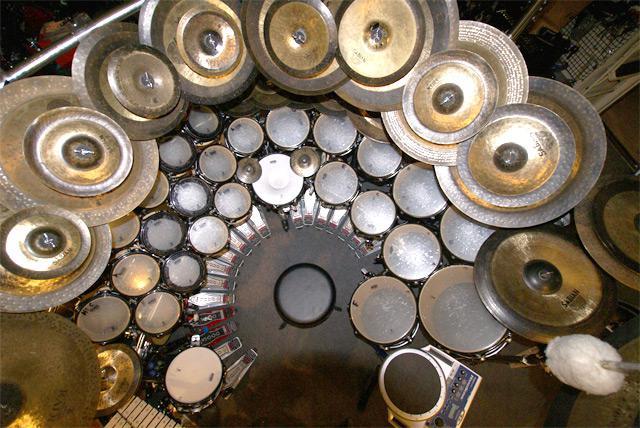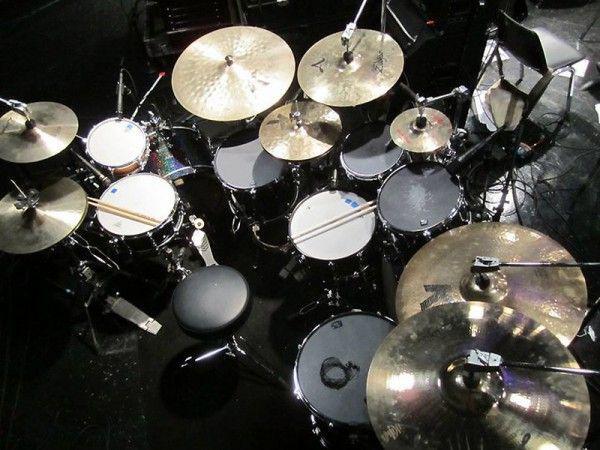The first image is the image on the left, the second image is the image on the right. Given the left and right images, does the statement "At least one image includes a hand holding a drum stick over the flat top of a drum." hold true? Answer yes or no. No. The first image is the image on the left, the second image is the image on the right. Analyze the images presented: Is the assertion "In at least one image there are at least two cymboles and one red drum." valid? Answer yes or no. No. 